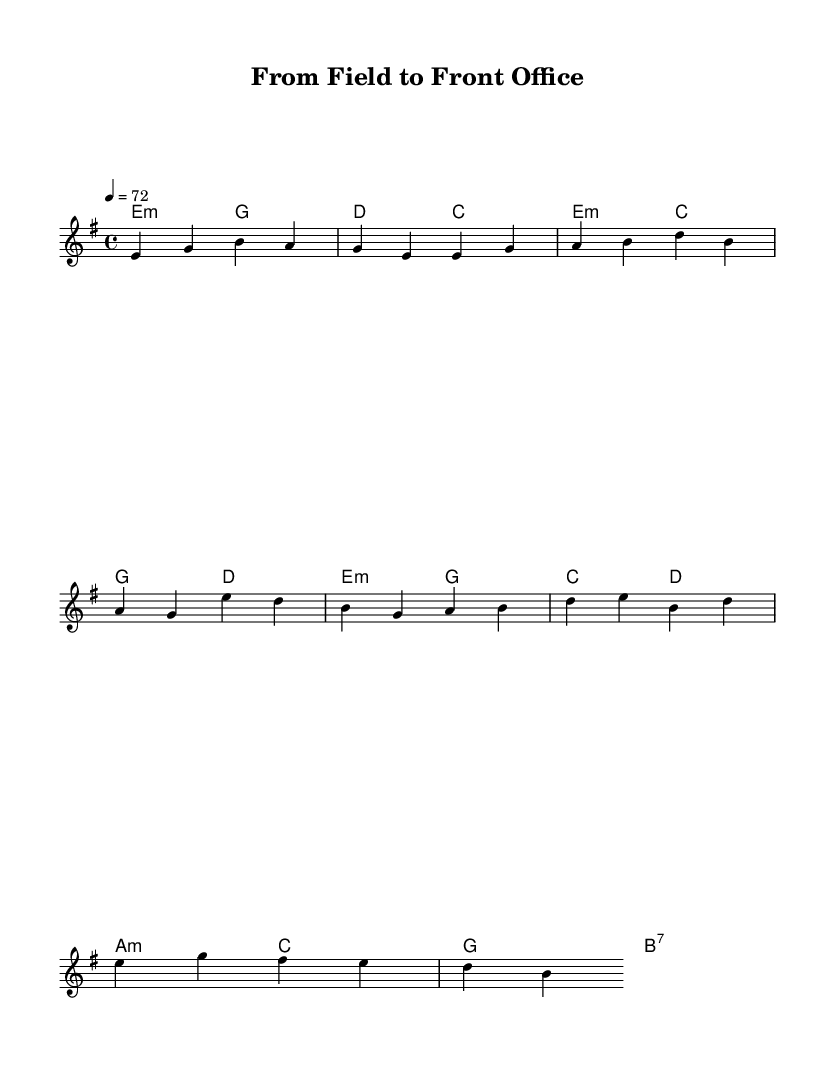What is the key signature of this music? The key signature is indicated by the key at the beginning of the score, which shows two sharps. This corresponds to E minor, which is the relative minor of G major.
Answer: E minor What is the time signature of this music? The time signature is located at the start of the score, which shows a "4/4" symbol. This indicates that there are four beats in each measure and a quarter note gets one beat.
Answer: 4/4 What is the tempo marking of the music? The tempo marking is seen in the text right after the time signature, which is "4 = 72". This indicates that there are 72 beats per minute, suggesting a moderate pace.
Answer: 72 How many measures are present in the music? By counting the measures in the score, each set of vertical lines represents a measure. There are 8 measures visible in the melody section.
Answer: 8 What is the final chord of the bridge section? The bridge section shows the chords on the printed score, and the final chord indicated there is a B7 chord, suggesting a seventh chord resolution typical in metal.
Answer: B7 What type of harmony is predominantly used in the music? The harmony is mostly minor, as the chords in the score indicate that the majority of the sections utilize minor chords, typical of metal ballads which often convey darker emotions.
Answer: Minor What lyrical themes are reflected in the sheet music? While the music itself does not contain lyrics, the title, "From Field to Front Office," and the mood created by the minor chords suggest themes of reflection, transition, and perhaps nostalgia, common in ballads.
Answer: Transition 